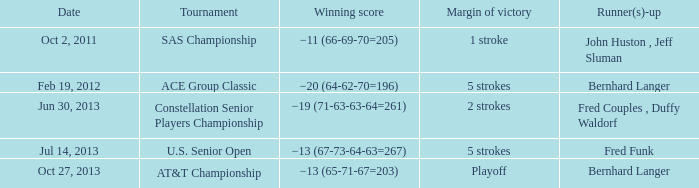Who is/are the second-place finisher(s) with a total score of -19 (71-63-63-64=261)? Fred Couples , Duffy Waldorf. 